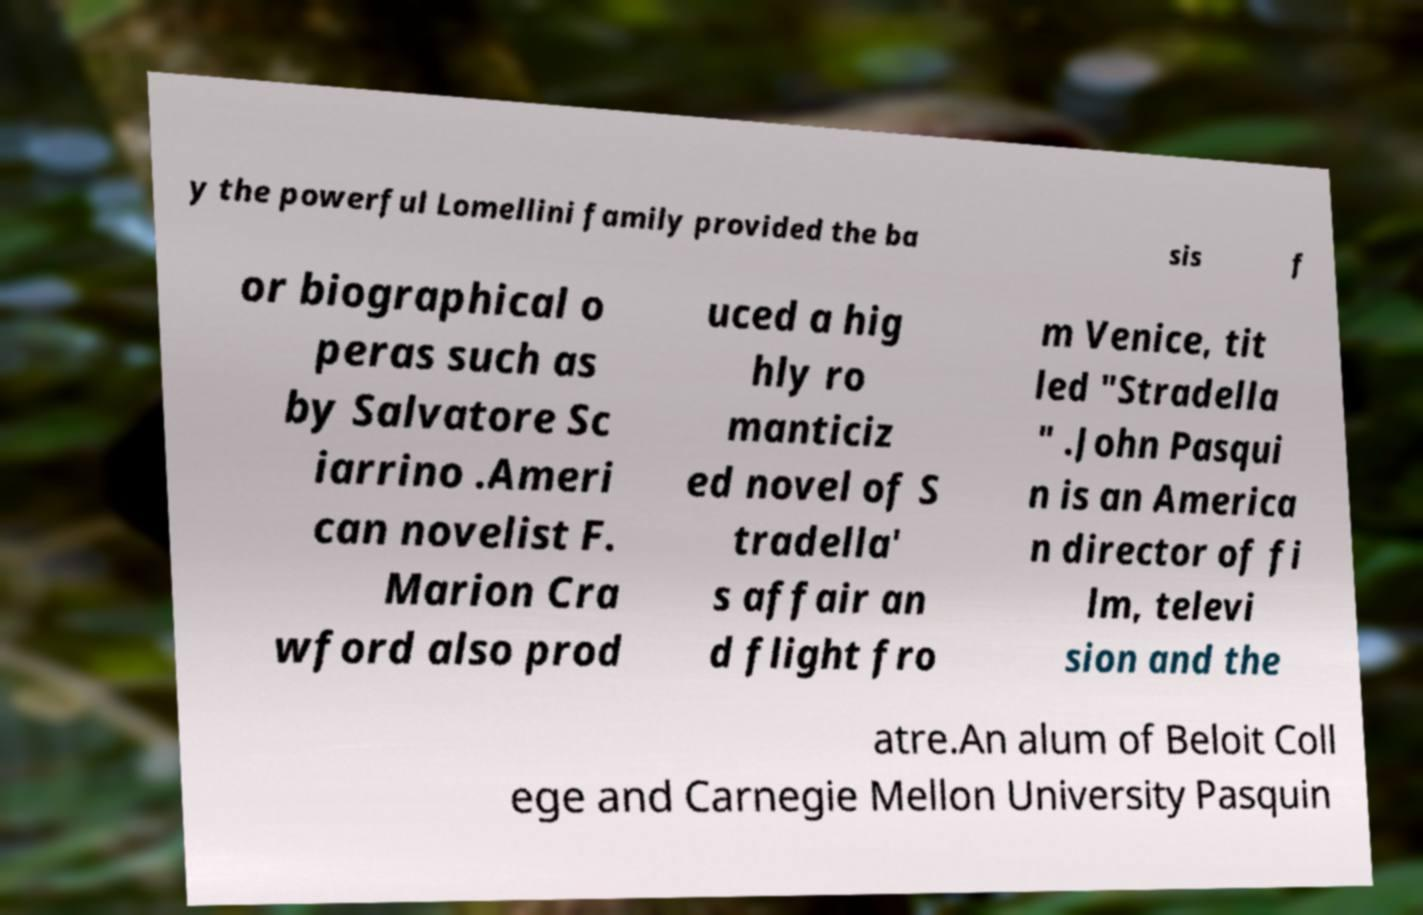I need the written content from this picture converted into text. Can you do that? y the powerful Lomellini family provided the ba sis f or biographical o peras such as by Salvatore Sc iarrino .Ameri can novelist F. Marion Cra wford also prod uced a hig hly ro manticiz ed novel of S tradella' s affair an d flight fro m Venice, tit led "Stradella " .John Pasqui n is an America n director of fi lm, televi sion and the atre.An alum of Beloit Coll ege and Carnegie Mellon University Pasquin 